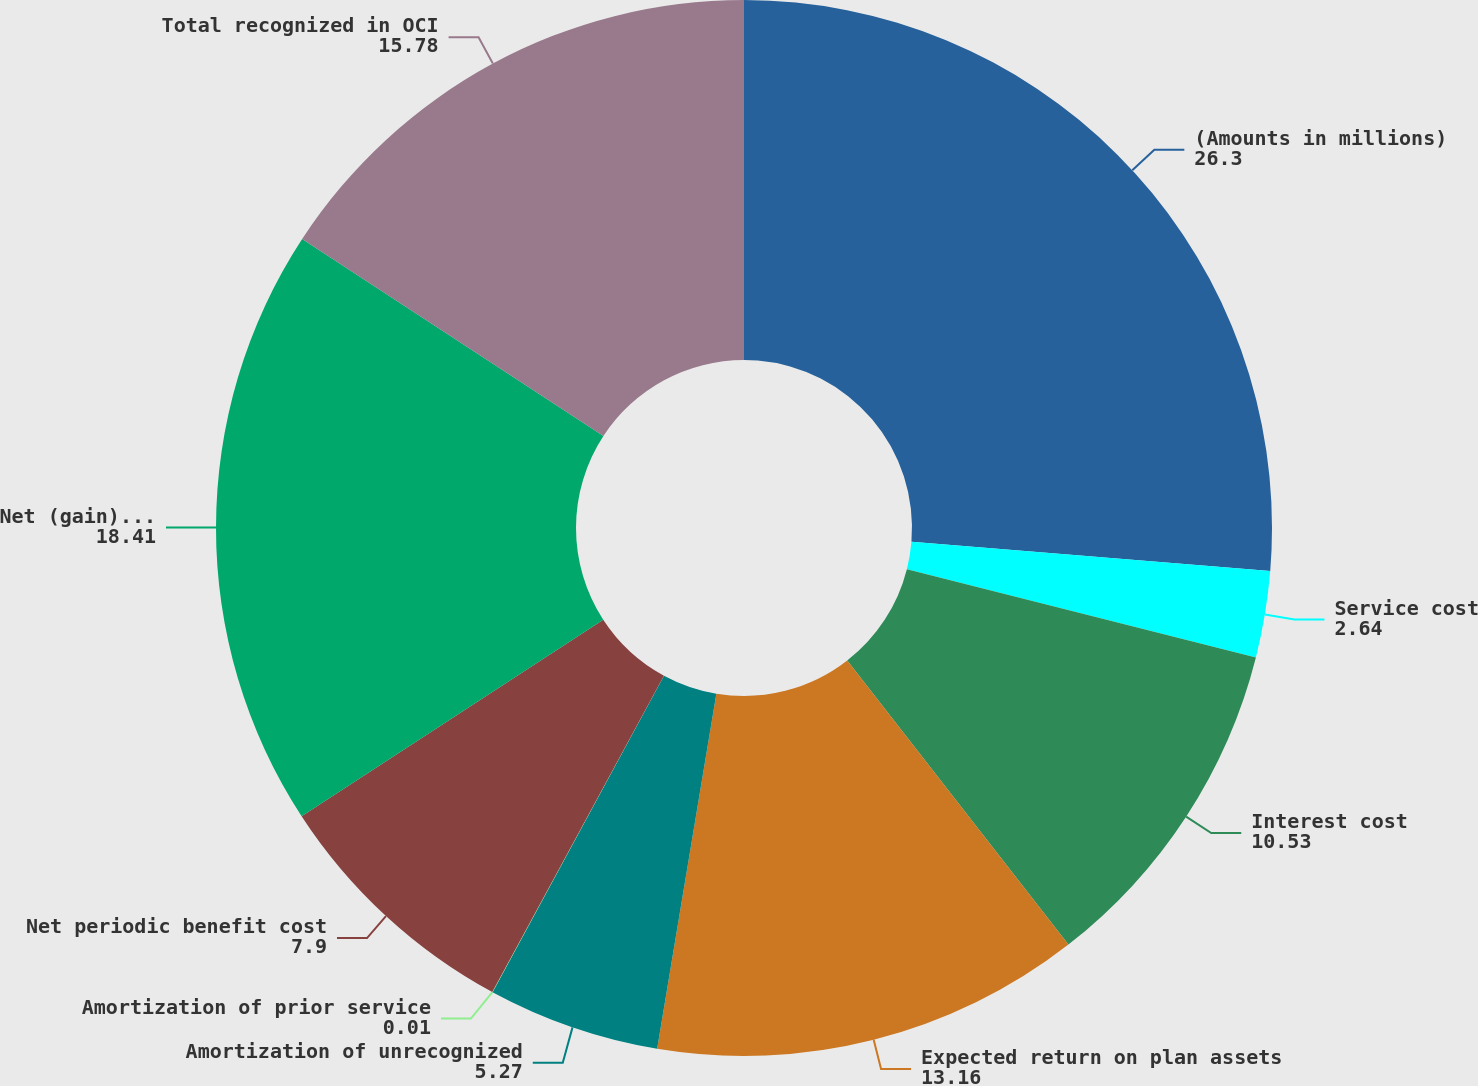Convert chart to OTSL. <chart><loc_0><loc_0><loc_500><loc_500><pie_chart><fcel>(Amounts in millions)<fcel>Service cost<fcel>Interest cost<fcel>Expected return on plan assets<fcel>Amortization of unrecognized<fcel>Amortization of prior service<fcel>Net periodic benefit cost<fcel>Net (gain) loss<fcel>Total recognized in OCI<nl><fcel>26.3%<fcel>2.64%<fcel>10.53%<fcel>13.16%<fcel>5.27%<fcel>0.01%<fcel>7.9%<fcel>18.41%<fcel>15.78%<nl></chart> 